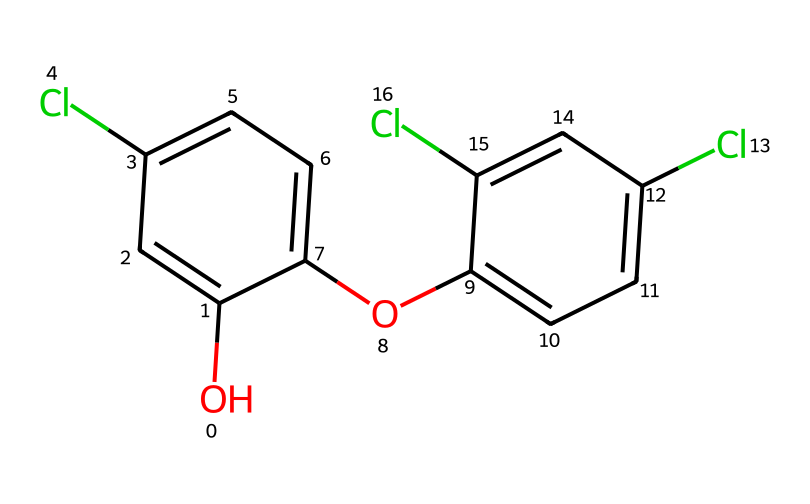What is the molecular formula of triclosan? To obtain the molecular formula, we need to count the number of each type of atom in the structure depicted by the SMILES. From the structure, there are 12 carbon (C) atoms, 9 hydrogen (H) atoms, 3 chlorine (Cl) atoms, and 1 oxygen (O) atom. Thus, the molecular formula is C12H9Cl3O.
Answer: C12H9Cl3O How many benzene rings are present in triclosan? By analyzing the structure, we can identify that there are two distinct benzene rings indicated by the 'c' in the SMILES, which represent carbon atoms in a cyclic arrangement with alternating double bonds.
Answer: 2 What type of functional group is present in triclosan? The presence of the -O- (ether) and -OH (hydroxyl) groups can be identified in the structure. The hydroxyl group is particularly crucial as it characterizes triclosan as an antibacterial agent.
Answer: hydroxyl How many chlorine atoms are attached to triclosan? The SMILES representation shows three chlorine (Cl) atoms bonded to the structure. Each 'Cl' indicates the presence of a chlorine atom directly attached to the benzene rings in the chemical structure.
Answer: 3 Is triclosan a symmetrical molecule? To determine symmetry, we look for identical halves in the chemical structure. The two benzene rings are arranged in such a way that they are not mirror images of each other due to the positions of the chlorine and hydroxyl groups. Thus, triclosan is not symmetrical.
Answer: no How many hydrogen atoms are replaced by chlorine in triclosan? Triclosan has a total of 9 hydrogen atoms. The three chlorine atoms in the structure effectively replace 3 hydrogen atoms from the original benzene rings. Thus, we can conclude that 3 hydrogen atoms are replaced by chlorine.
Answer: 3 